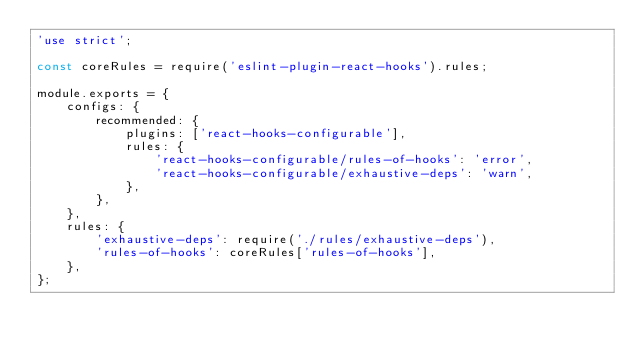Convert code to text. <code><loc_0><loc_0><loc_500><loc_500><_JavaScript_>'use strict';

const coreRules = require('eslint-plugin-react-hooks').rules;

module.exports = {
    configs: {
        recommended: {
            plugins: ['react-hooks-configurable'],
            rules: {
                'react-hooks-configurable/rules-of-hooks': 'error',
                'react-hooks-configurable/exhaustive-deps': 'warn',
            },
        },
    },
    rules: {
        'exhaustive-deps': require('./rules/exhaustive-deps'),
        'rules-of-hooks': coreRules['rules-of-hooks'],
    },
};
</code> 